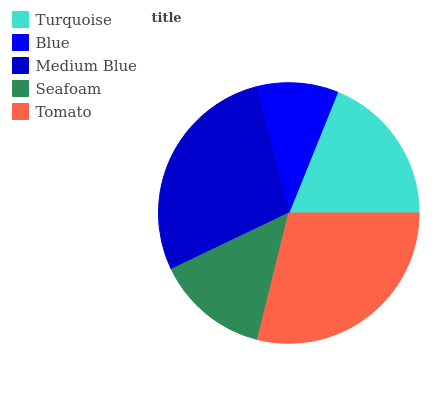Is Blue the minimum?
Answer yes or no. Yes. Is Tomato the maximum?
Answer yes or no. Yes. Is Medium Blue the minimum?
Answer yes or no. No. Is Medium Blue the maximum?
Answer yes or no. No. Is Medium Blue greater than Blue?
Answer yes or no. Yes. Is Blue less than Medium Blue?
Answer yes or no. Yes. Is Blue greater than Medium Blue?
Answer yes or no. No. Is Medium Blue less than Blue?
Answer yes or no. No. Is Turquoise the high median?
Answer yes or no. Yes. Is Turquoise the low median?
Answer yes or no. Yes. Is Tomato the high median?
Answer yes or no. No. Is Tomato the low median?
Answer yes or no. No. 